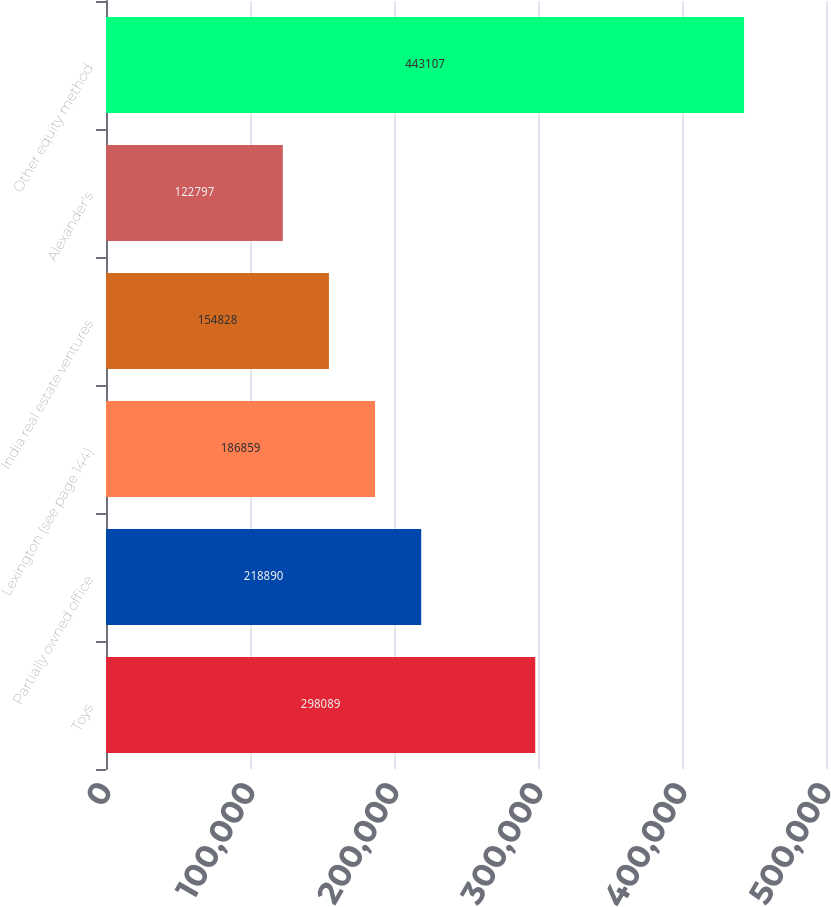<chart> <loc_0><loc_0><loc_500><loc_500><bar_chart><fcel>Toys<fcel>Partially owned office<fcel>Lexington (see page 144)<fcel>India real estate ventures<fcel>Alexander's<fcel>Other equity method<nl><fcel>298089<fcel>218890<fcel>186859<fcel>154828<fcel>122797<fcel>443107<nl></chart> 